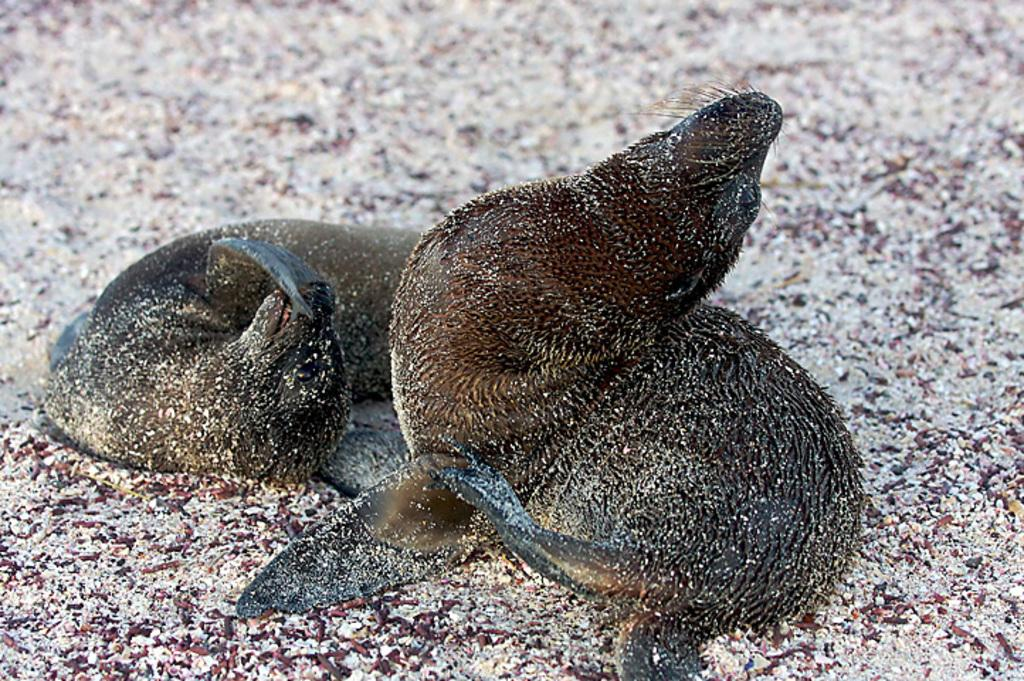How many animals are present in the image? There are two animals in the image. Can you describe the objects on the surface in the image? Unfortunately, the provided facts do not give any information about the objects on the surface in the image. What is the interest rate on the car in the image? There is no car present in the image, so it is not possible to determine the interest rate. 